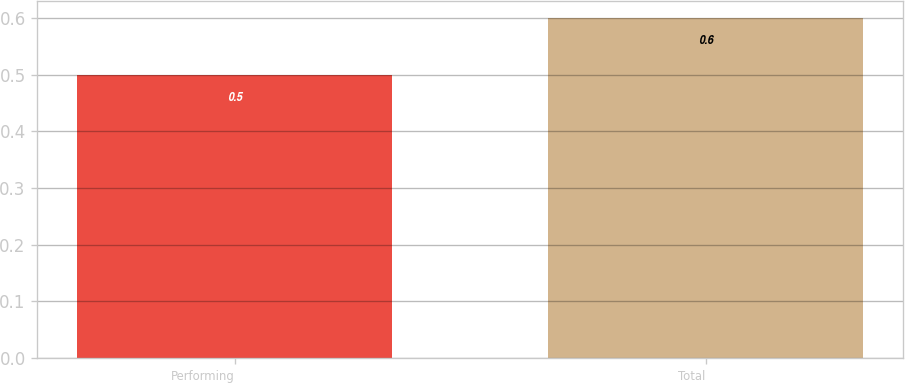<chart> <loc_0><loc_0><loc_500><loc_500><bar_chart><fcel>Performing<fcel>Total<nl><fcel>0.5<fcel>0.6<nl></chart> 